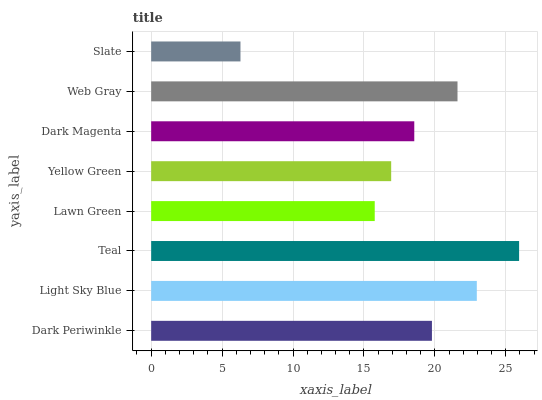Is Slate the minimum?
Answer yes or no. Yes. Is Teal the maximum?
Answer yes or no. Yes. Is Light Sky Blue the minimum?
Answer yes or no. No. Is Light Sky Blue the maximum?
Answer yes or no. No. Is Light Sky Blue greater than Dark Periwinkle?
Answer yes or no. Yes. Is Dark Periwinkle less than Light Sky Blue?
Answer yes or no. Yes. Is Dark Periwinkle greater than Light Sky Blue?
Answer yes or no. No. Is Light Sky Blue less than Dark Periwinkle?
Answer yes or no. No. Is Dark Periwinkle the high median?
Answer yes or no. Yes. Is Dark Magenta the low median?
Answer yes or no. Yes. Is Web Gray the high median?
Answer yes or no. No. Is Slate the low median?
Answer yes or no. No. 